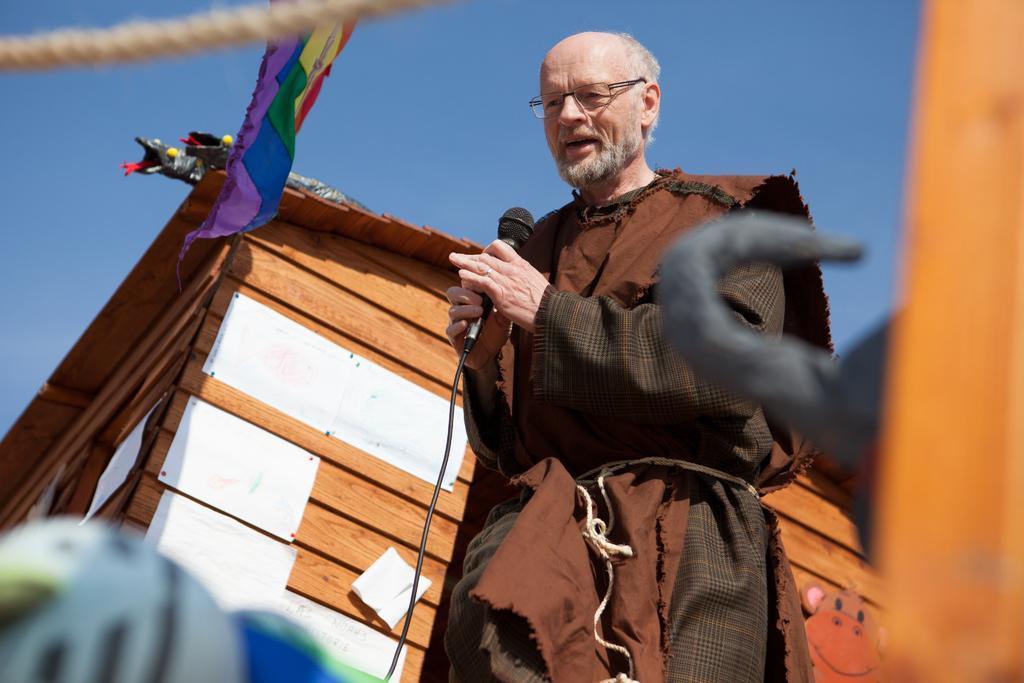Please provide a concise description of this image. In this picture we can see a man with spectacles and he is holding a microphone with a cable. In front of the man, there are blurred objects. Behind the man, there is a house and the sky. At the top of the image, there is a rope and a flag. 